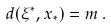Convert formula to latex. <formula><loc_0><loc_0><loc_500><loc_500>d ( \xi ^ { * } , x _ { * } ) = m \, .</formula> 